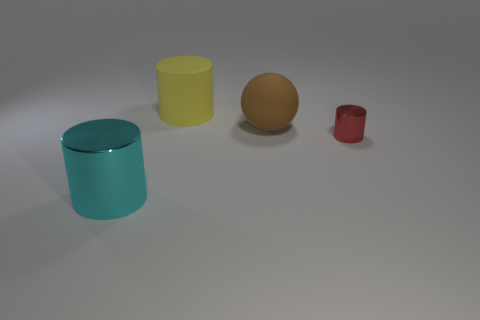Add 1 blue matte things. How many objects exist? 5 Subtract all spheres. How many objects are left? 3 Subtract 1 brown spheres. How many objects are left? 3 Subtract all yellow cylinders. Subtract all brown things. How many objects are left? 2 Add 1 large brown balls. How many large brown balls are left? 2 Add 2 large objects. How many large objects exist? 5 